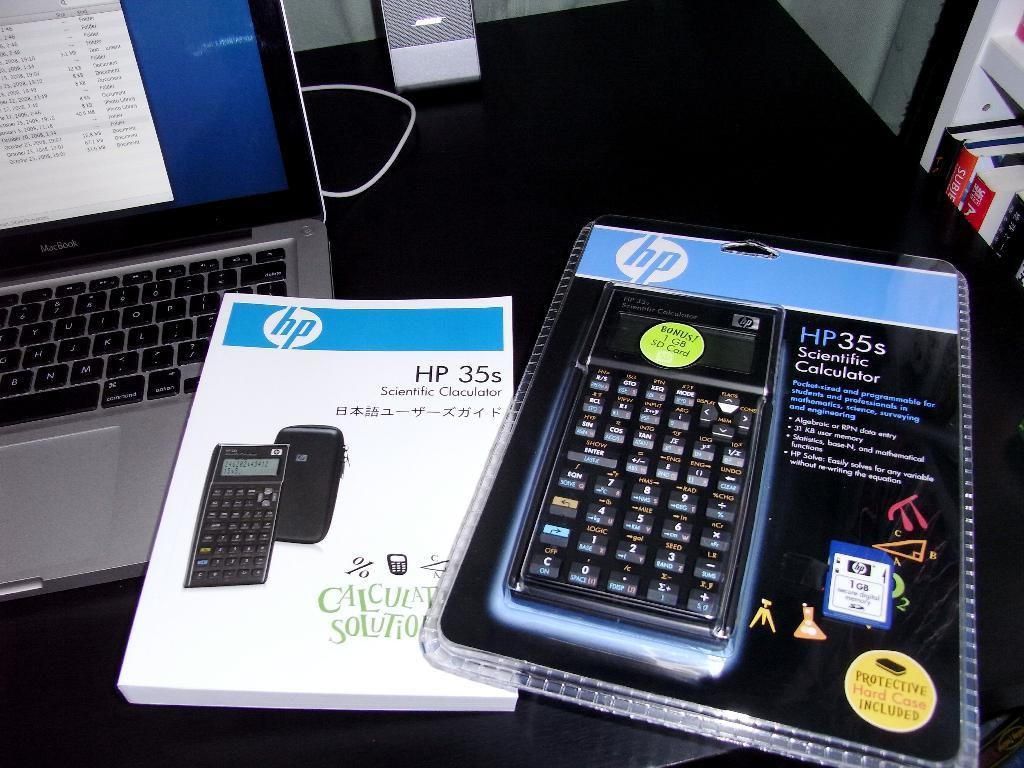<image>
Relay a brief, clear account of the picture shown. a closed hp35s scientific calculator next to a guide book of it 